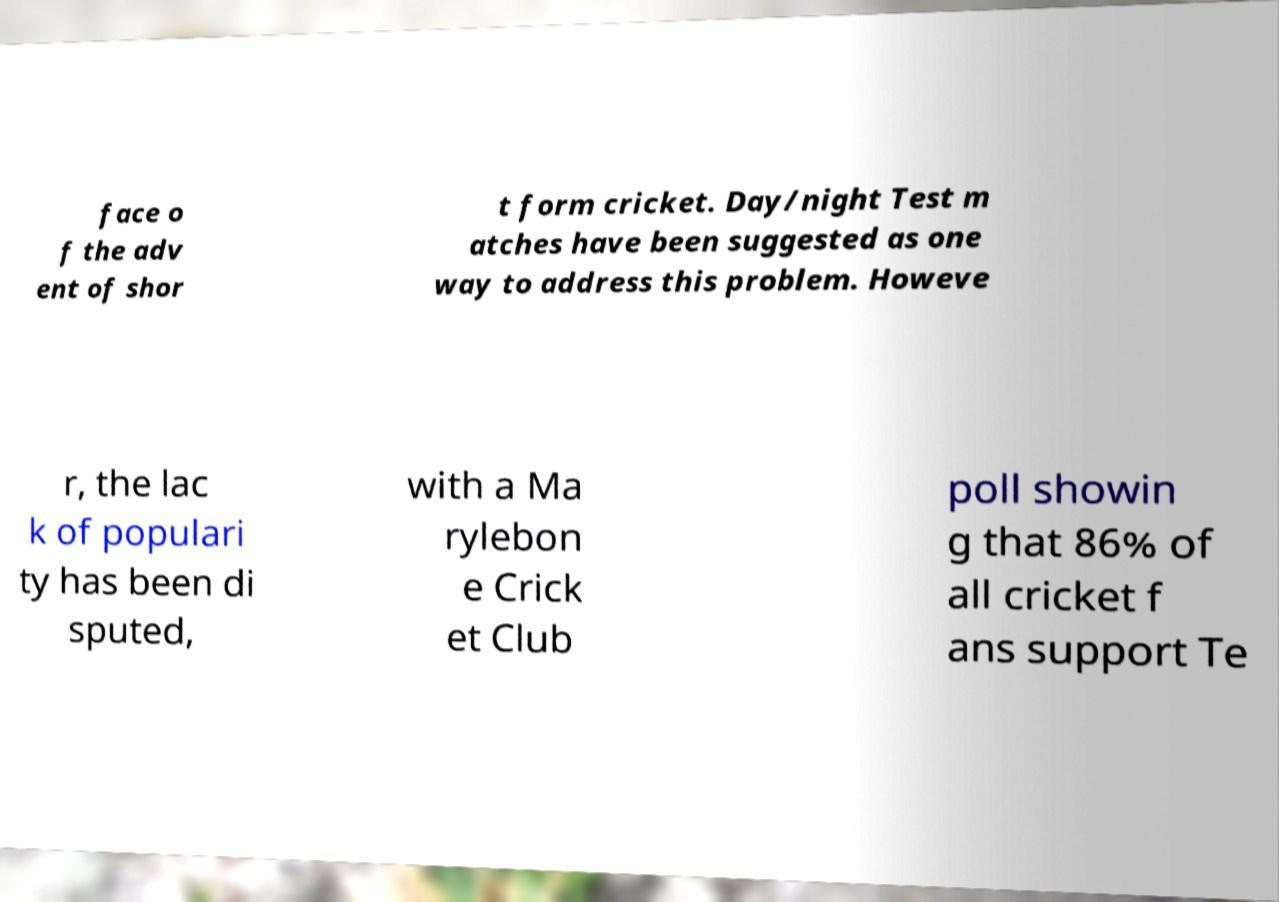I need the written content from this picture converted into text. Can you do that? face o f the adv ent of shor t form cricket. Day/night Test m atches have been suggested as one way to address this problem. Howeve r, the lac k of populari ty has been di sputed, with a Ma rylebon e Crick et Club poll showin g that 86% of all cricket f ans support Te 